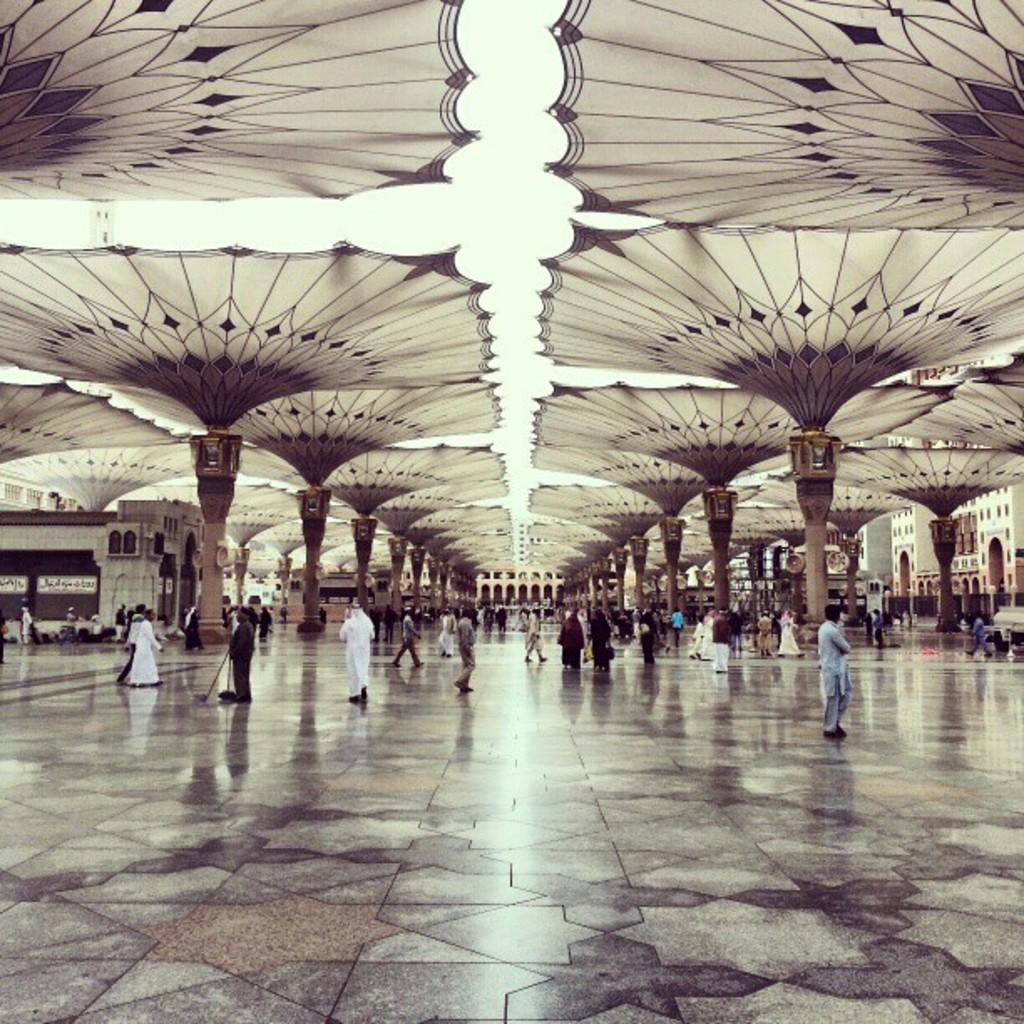Who or what can be seen in the image? There are people in the image. What are the people doing in the image? The people are walking on the floor. Where are the people located in the image? The people are under tents. What type of potato is being crushed by the people in the image? There is no potato present in the image, nor is there any indication of crushing or any other activity involving a potato. 